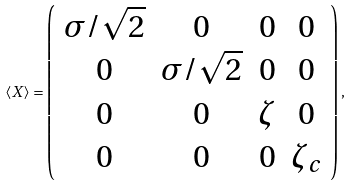<formula> <loc_0><loc_0><loc_500><loc_500>\langle X \rangle = \left ( \begin{array} { c c c c } \sigma / \sqrt { 2 } & 0 & 0 & 0 \\ 0 & \sigma / \sqrt { 2 } & 0 & 0 \\ 0 & 0 & \zeta & 0 \\ 0 & 0 & 0 & \zeta _ { c } \\ \end{array} \right ) ,</formula> 